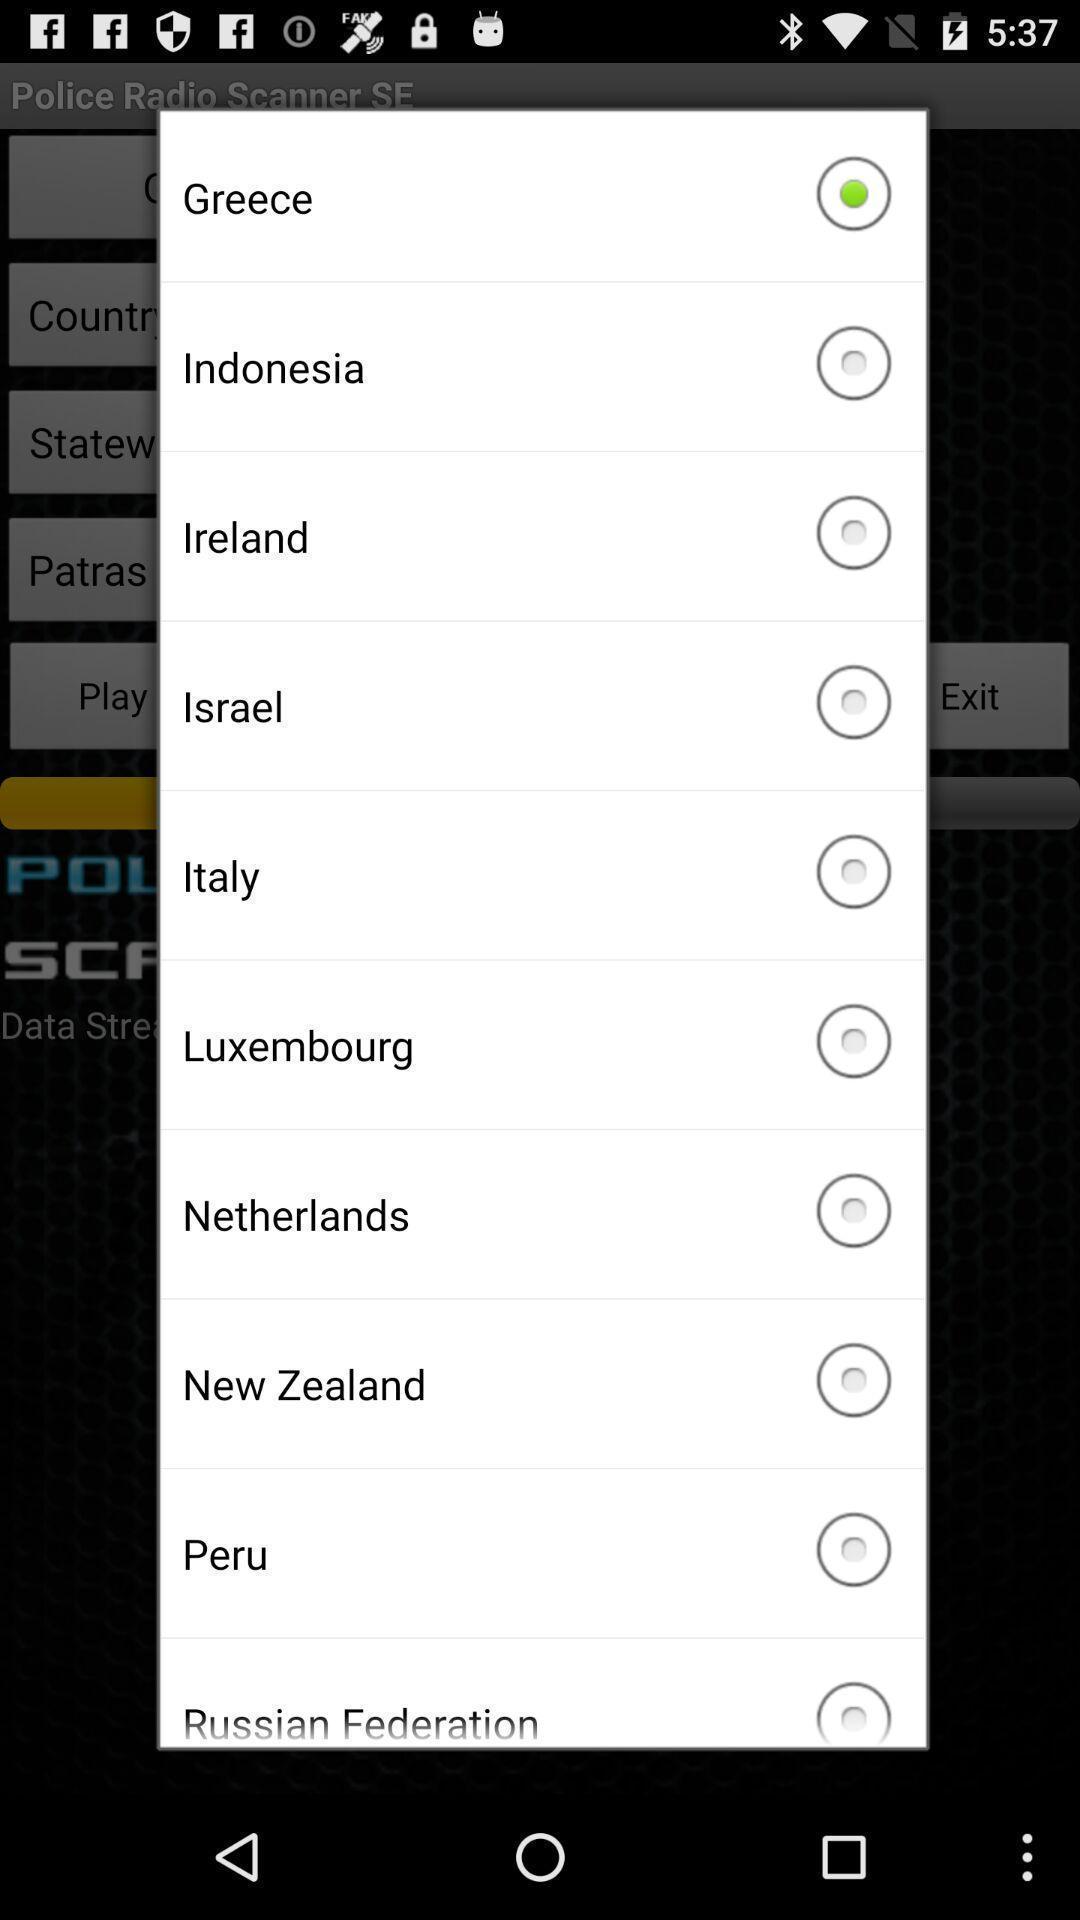Provide a textual representation of this image. Pop-up showing multiple options to choose a country. 